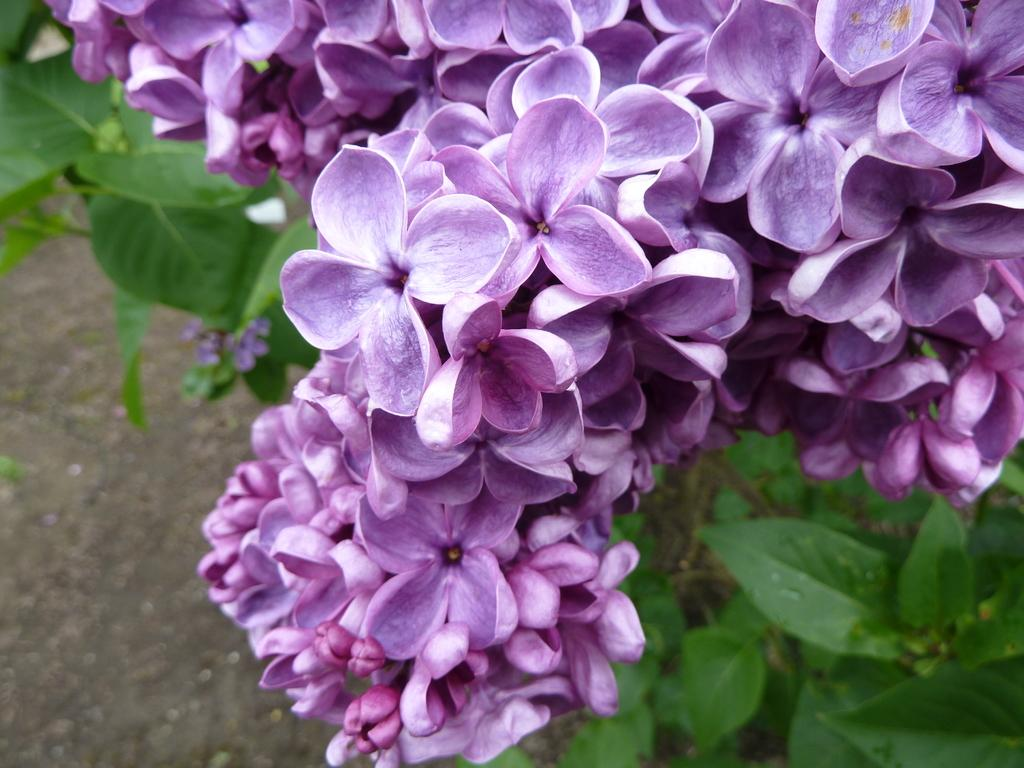What type of flowers can be seen in the image? There are purple flowers in the image. What are the flowers a part of? The flowers are for a plant. What position does the rainstorm hold in the image? There is no rainstorm present in the image. What is the reason behind the flowers' existence in the image? The reason behind the flowers' existence in the image is simply that they are a part of the plant, and no other specific reason is mentioned or implied. 